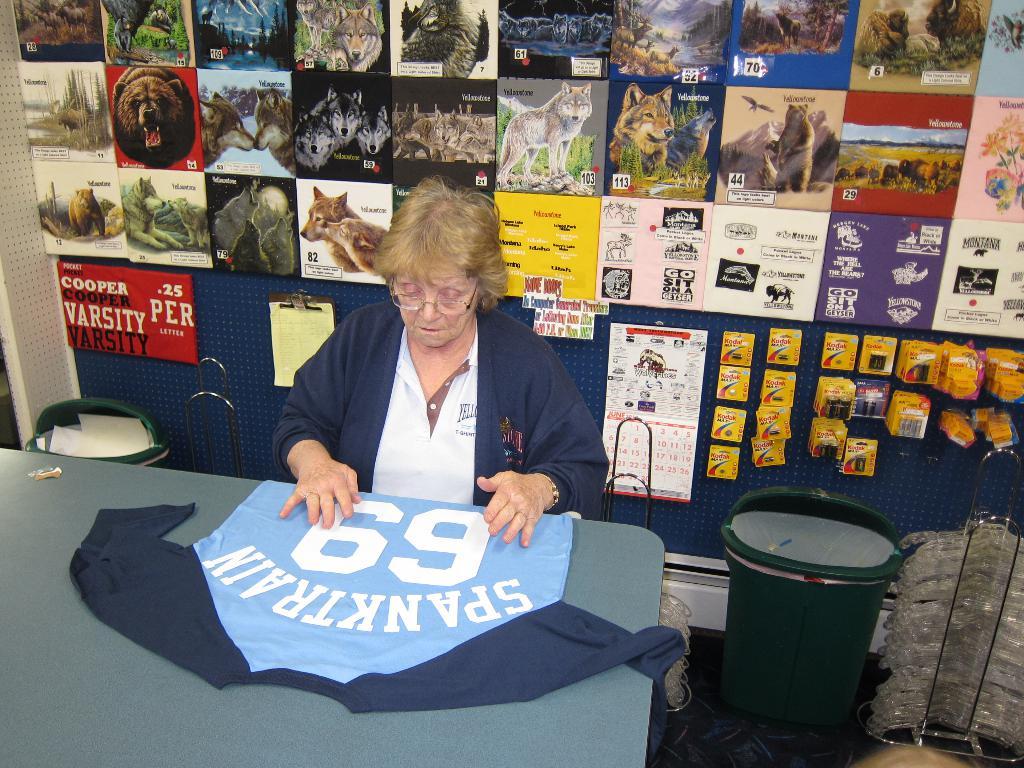What is the number on the jersey?
Offer a terse response. 69. What player is on the jersey?
Offer a very short reply. Spanktrain. 